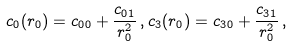<formula> <loc_0><loc_0><loc_500><loc_500>c _ { 0 } ( r _ { 0 } ) = c _ { 0 0 } + \frac { c _ { 0 1 } } { r _ { 0 } ^ { 2 } } \, , c _ { 3 } ( r _ { 0 } ) = c _ { 3 0 } + \frac { c _ { 3 1 } } { r _ { 0 } ^ { 2 } } \, ,</formula> 